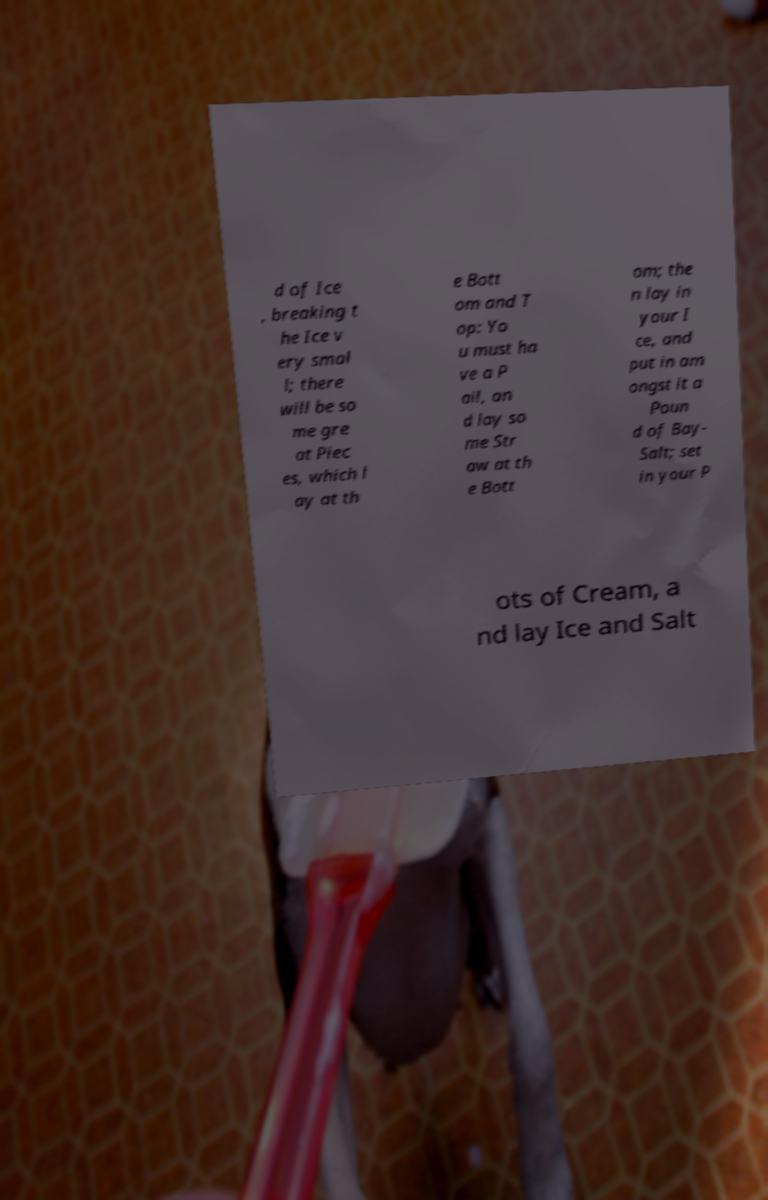What messages or text are displayed in this image? I need them in a readable, typed format. d of Ice , breaking t he Ice v ery smal l; there will be so me gre at Piec es, which l ay at th e Bott om and T op: Yo u must ha ve a P ail, an d lay so me Str aw at th e Bott om; the n lay in your I ce, and put in am ongst it a Poun d of Bay- Salt; set in your P ots of Cream, a nd lay Ice and Salt 